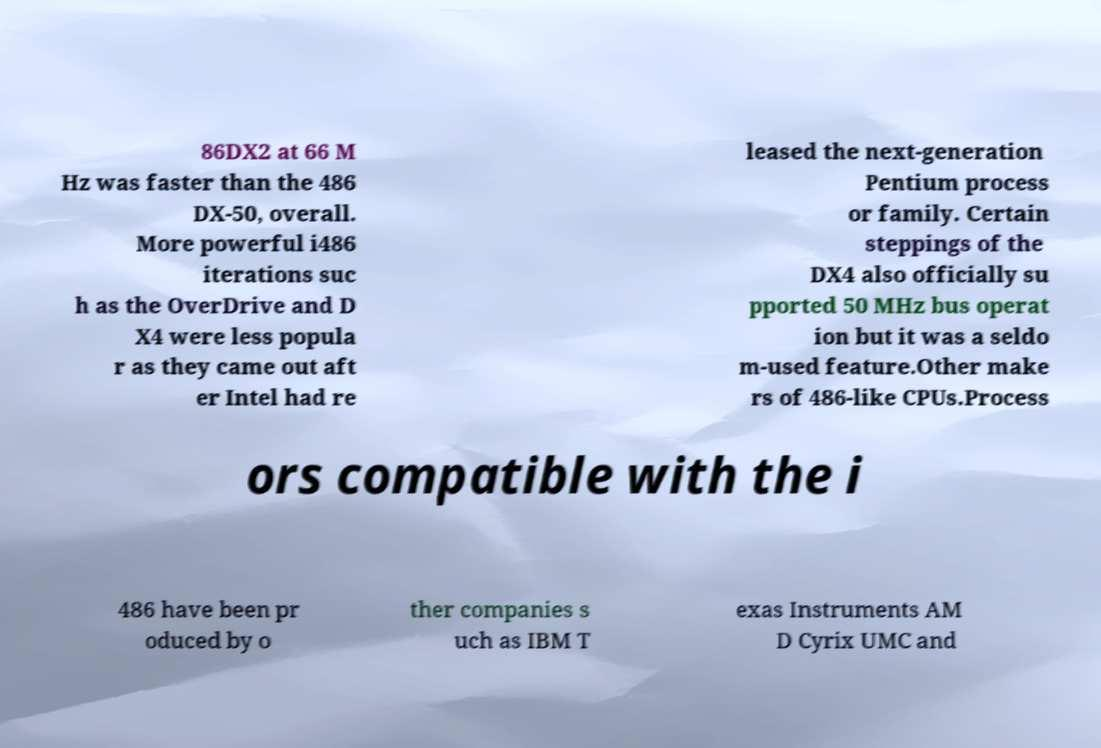There's text embedded in this image that I need extracted. Can you transcribe it verbatim? 86DX2 at 66 M Hz was faster than the 486 DX-50, overall. More powerful i486 iterations suc h as the OverDrive and D X4 were less popula r as they came out aft er Intel had re leased the next-generation Pentium process or family. Certain steppings of the DX4 also officially su pported 50 MHz bus operat ion but it was a seldo m-used feature.Other make rs of 486-like CPUs.Process ors compatible with the i 486 have been pr oduced by o ther companies s uch as IBM T exas Instruments AM D Cyrix UMC and 